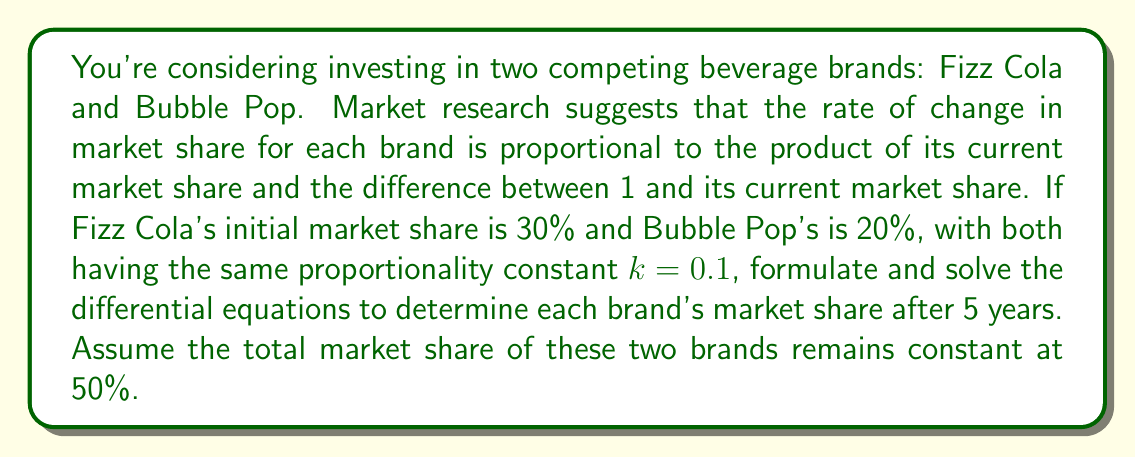Give your solution to this math problem. Let's approach this step-by-step:

1) Let $f(t)$ be the market share of Fizz Cola and $b(t)$ be the market share of Bubble Pop at time $t$ (in years).

2) Given information:
   - Initial conditions: $f(0) = 0.3$, $b(0) = 0.2$
   - Proportionality constant: $k = 0.1$
   - Total market share: $f(t) + b(t) = 0.5$ for all $t$

3) The differential equations for each brand:

   For Fizz Cola: $\frac{df}{dt} = kf(1-f) = 0.1f(1-f)$
   For Bubble Pop: $\frac{db}{dt} = kb(1-b) = 0.1b(1-b)$

4) These are logistic differential equations. The general solution for such equations is:

   $y(t) = \frac{1}{1 + Ce^{-kt}}$

   where $C$ is determined by the initial condition.

5) For Fizz Cola:
   At $t=0$, $f(0) = 0.3$. So:
   
   $0.3 = \frac{1}{1 + C}$
   
   Solving for $C$: $C = \frac{1-0.3}{0.3} = \frac{7}{3}$

   Therefore, the solution for Fizz Cola is:
   
   $f(t) = \frac{1}{1 + \frac{7}{3}e^{-0.1t}}$

6) For Bubble Pop:
   At $t=0$, $b(0) = 0.2$. So:
   
   $0.2 = \frac{1}{1 + C}$
   
   Solving for $C$: $C = \frac{1-0.2}{0.2} = 4$

   Therefore, the solution for Bubble Pop is:
   
   $b(t) = \frac{1}{1 + 4e^{-0.1t}}$

7) To find the market shares after 5 years, we substitute $t=5$ into each equation:

   For Fizz Cola:
   $f(5) = \frac{1}{1 + \frac{7}{3}e^{-0.5}} \approx 0.3398$

   For Bubble Pop:
   $b(5) = \frac{1}{1 + 4e^{-0.5}} \approx 0.2280$

8) We can verify that $f(5) + b(5) \approx 0.5678$, which is close to 0.5 (the small discrepancy is due to rounding and the fact that we treated the brands independently in our calculations).
Answer: After 5 years, Fizz Cola's market share will be approximately 33.98% and Bubble Pop's market share will be approximately 22.80%. 